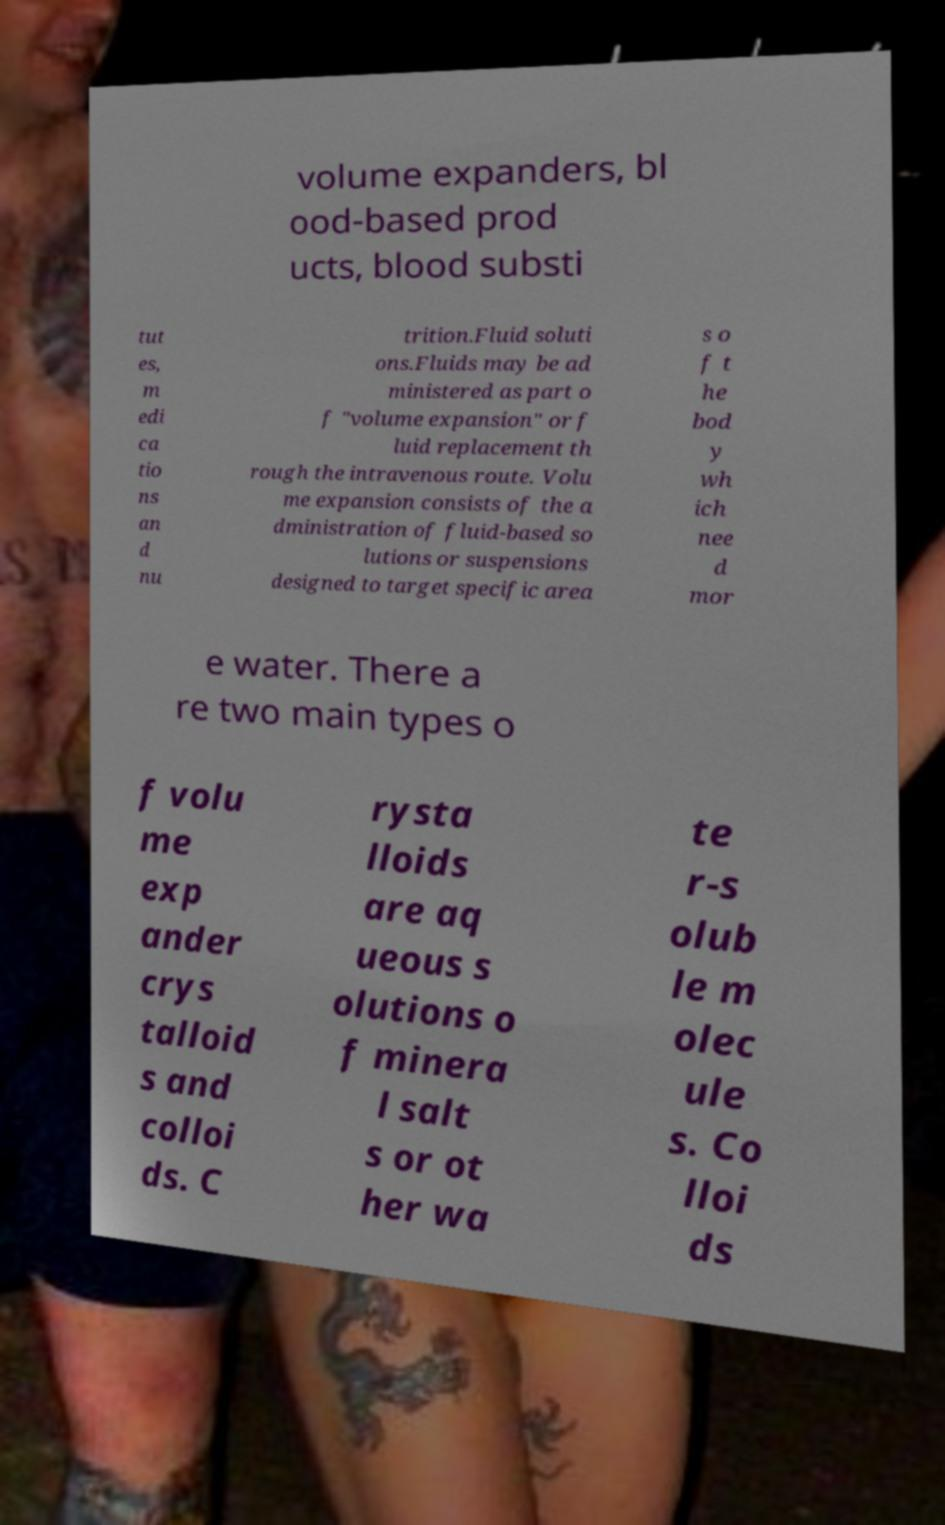What messages or text are displayed in this image? I need them in a readable, typed format. volume expanders, bl ood-based prod ucts, blood substi tut es, m edi ca tio ns an d nu trition.Fluid soluti ons.Fluids may be ad ministered as part o f "volume expansion" or f luid replacement th rough the intravenous route. Volu me expansion consists of the a dministration of fluid-based so lutions or suspensions designed to target specific area s o f t he bod y wh ich nee d mor e water. There a re two main types o f volu me exp ander crys talloid s and colloi ds. C rysta lloids are aq ueous s olutions o f minera l salt s or ot her wa te r-s olub le m olec ule s. Co lloi ds 